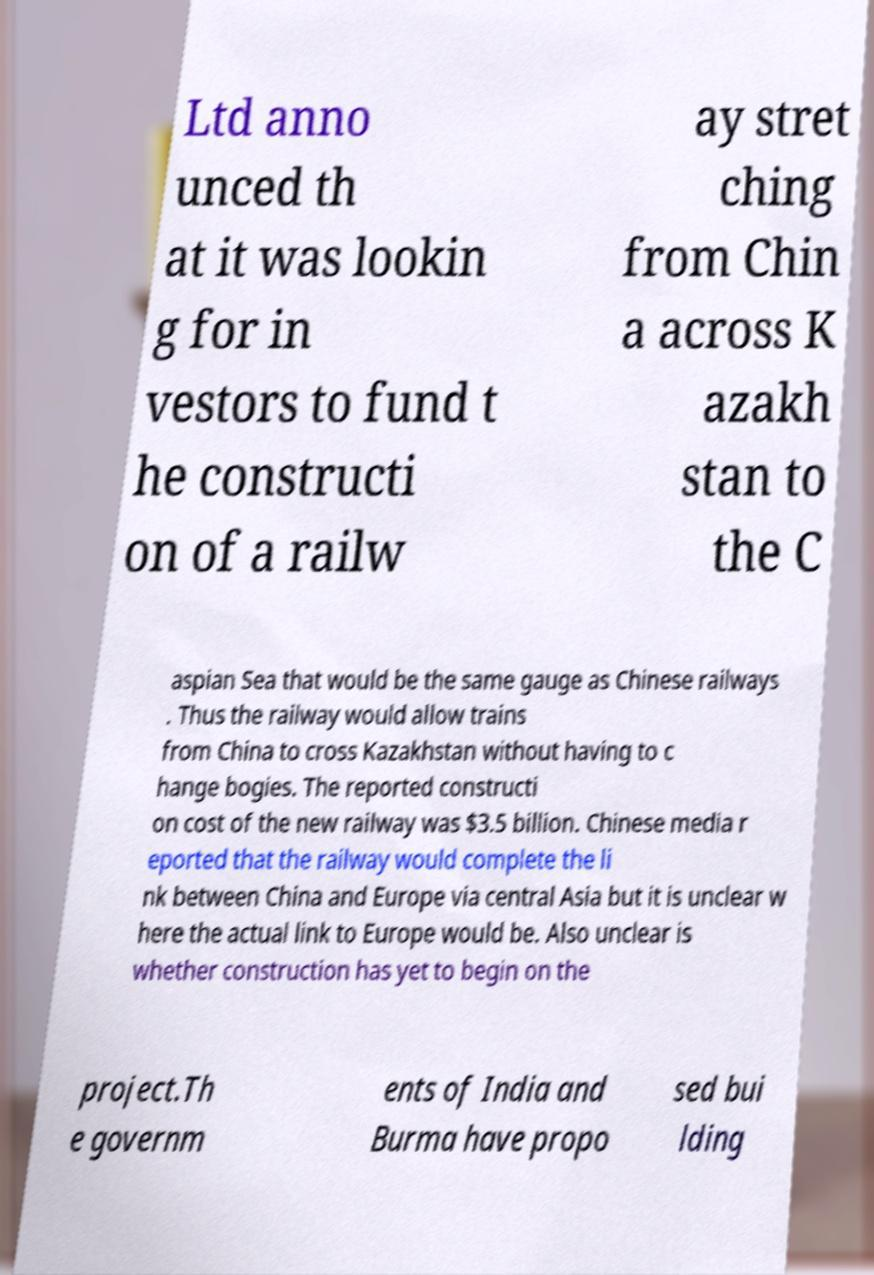Could you extract and type out the text from this image? Ltd anno unced th at it was lookin g for in vestors to fund t he constructi on of a railw ay stret ching from Chin a across K azakh stan to the C aspian Sea that would be the same gauge as Chinese railways . Thus the railway would allow trains from China to cross Kazakhstan without having to c hange bogies. The reported constructi on cost of the new railway was $3.5 billion. Chinese media r eported that the railway would complete the li nk between China and Europe via central Asia but it is unclear w here the actual link to Europe would be. Also unclear is whether construction has yet to begin on the project.Th e governm ents of India and Burma have propo sed bui lding 